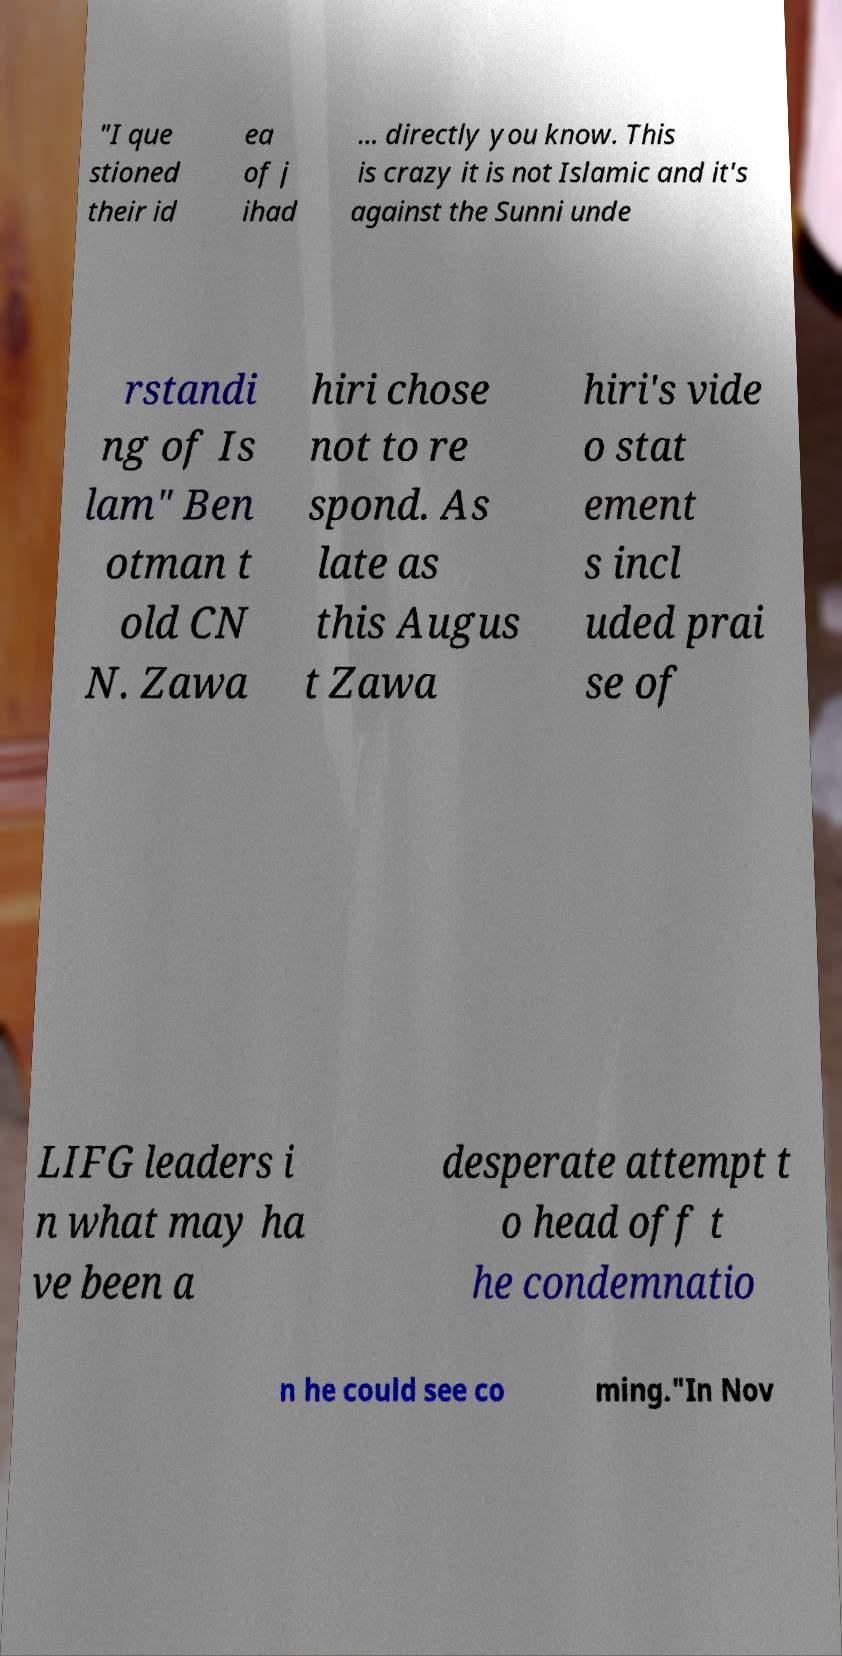Can you accurately transcribe the text from the provided image for me? "I que stioned their id ea of j ihad ... directly you know. This is crazy it is not Islamic and it's against the Sunni unde rstandi ng of Is lam" Ben otman t old CN N. Zawa hiri chose not to re spond. As late as this Augus t Zawa hiri's vide o stat ement s incl uded prai se of LIFG leaders i n what may ha ve been a desperate attempt t o head off t he condemnatio n he could see co ming."In Nov 